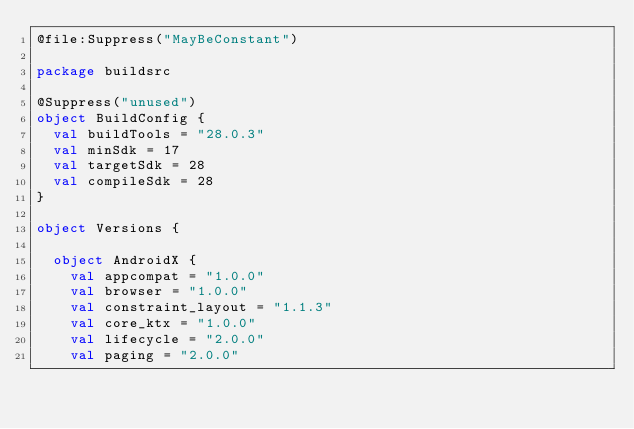Convert code to text. <code><loc_0><loc_0><loc_500><loc_500><_Kotlin_>@file:Suppress("MayBeConstant")

package buildsrc

@Suppress("unused")
object BuildConfig {
  val buildTools = "28.0.3"
  val minSdk = 17
  val targetSdk = 28
  val compileSdk = 28
}

object Versions {

  object AndroidX {
    val appcompat = "1.0.0"
    val browser = "1.0.0"
    val constraint_layout = "1.1.3"
    val core_ktx = "1.0.0"
    val lifecycle = "2.0.0"
    val paging = "2.0.0"</code> 